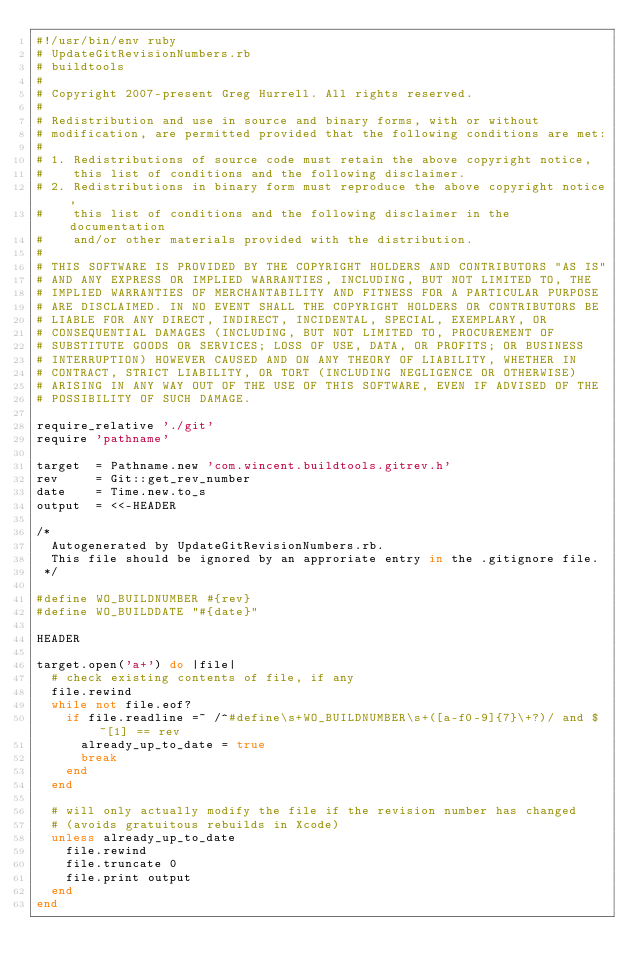<code> <loc_0><loc_0><loc_500><loc_500><_Ruby_>#!/usr/bin/env ruby
# UpdateGitRevisionNumbers.rb
# buildtools
#
# Copyright 2007-present Greg Hurrell. All rights reserved.
#
# Redistribution and use in source and binary forms, with or without
# modification, are permitted provided that the following conditions are met:
#
# 1. Redistributions of source code must retain the above copyright notice,
#    this list of conditions and the following disclaimer.
# 2. Redistributions in binary form must reproduce the above copyright notice,
#    this list of conditions and the following disclaimer in the documentation
#    and/or other materials provided with the distribution.
#
# THIS SOFTWARE IS PROVIDED BY THE COPYRIGHT HOLDERS AND CONTRIBUTORS "AS IS"
# AND ANY EXPRESS OR IMPLIED WARRANTIES, INCLUDING, BUT NOT LIMITED TO, THE
# IMPLIED WARRANTIES OF MERCHANTABILITY AND FITNESS FOR A PARTICULAR PURPOSE
# ARE DISCLAIMED. IN NO EVENT SHALL THE COPYRIGHT HOLDERS OR CONTRIBUTORS BE
# LIABLE FOR ANY DIRECT, INDIRECT, INCIDENTAL, SPECIAL, EXEMPLARY, OR
# CONSEQUENTIAL DAMAGES (INCLUDING, BUT NOT LIMITED TO, PROCUREMENT OF
# SUBSTITUTE GOODS OR SERVICES; LOSS OF USE, DATA, OR PROFITS; OR BUSINESS
# INTERRUPTION) HOWEVER CAUSED AND ON ANY THEORY OF LIABILITY, WHETHER IN
# CONTRACT, STRICT LIABILITY, OR TORT (INCLUDING NEGLIGENCE OR OTHERWISE)
# ARISING IN ANY WAY OUT OF THE USE OF THIS SOFTWARE, EVEN IF ADVISED OF THE
# POSSIBILITY OF SUCH DAMAGE.

require_relative './git'
require 'pathname'

target  = Pathname.new 'com.wincent.buildtools.gitrev.h'
rev     = Git::get_rev_number
date    = Time.new.to_s
output  = <<-HEADER

/*
  Autogenerated by UpdateGitRevisionNumbers.rb.
  This file should be ignored by an approriate entry in the .gitignore file.
 */

#define WO_BUILDNUMBER #{rev}
#define WO_BUILDDATE "#{date}"

HEADER

target.open('a+') do |file|
  # check existing contents of file, if any
  file.rewind
  while not file.eof?
    if file.readline =~ /^#define\s+WO_BUILDNUMBER\s+([a-f0-9]{7}\+?)/ and $~[1] == rev
      already_up_to_date = true
      break
    end
  end

  # will only actually modify the file if the revision number has changed
  # (avoids gratuitous rebuilds in Xcode)
  unless already_up_to_date
    file.rewind
    file.truncate 0
    file.print output
  end
end
</code> 